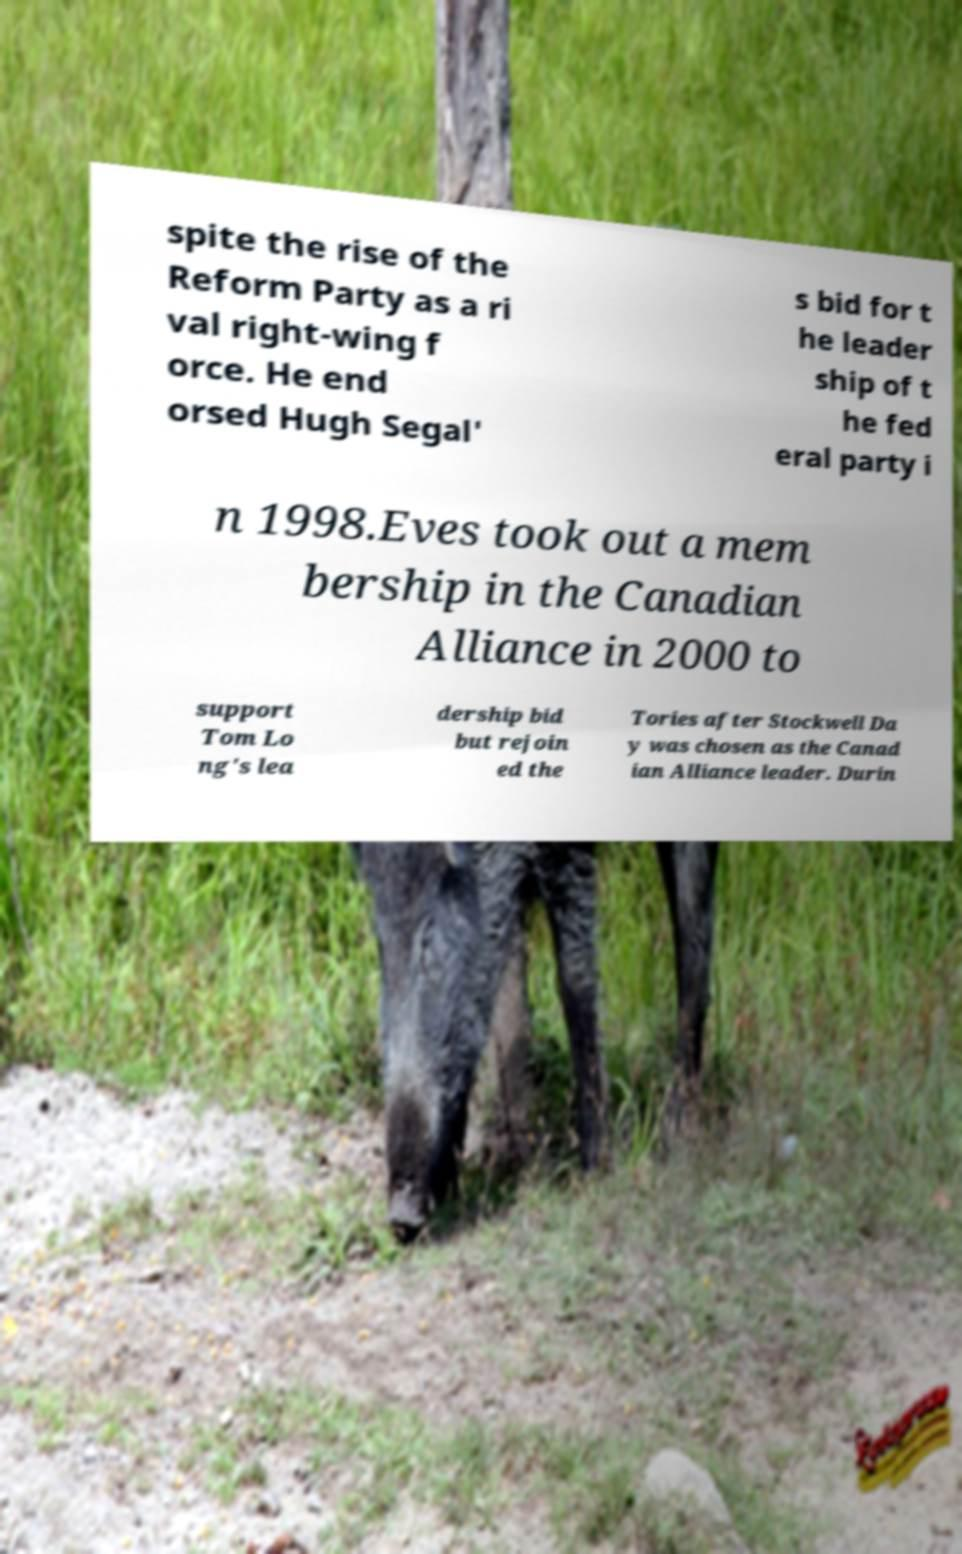I need the written content from this picture converted into text. Can you do that? spite the rise of the Reform Party as a ri val right-wing f orce. He end orsed Hugh Segal' s bid for t he leader ship of t he fed eral party i n 1998.Eves took out a mem bership in the Canadian Alliance in 2000 to support Tom Lo ng's lea dership bid but rejoin ed the Tories after Stockwell Da y was chosen as the Canad ian Alliance leader. Durin 